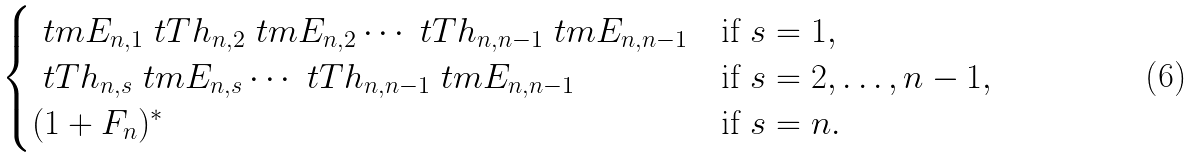Convert formula to latex. <formula><loc_0><loc_0><loc_500><loc_500>\begin{cases} \ t m E _ { n , 1 } \ t T h _ { n , 2 } \ t m E _ { n , 2 } \cdots \ t T h _ { n , n - 1 } \ t m E _ { n , n - 1 } & \text {if } s = 1 , \\ \ t T h _ { n , s } \ t m E _ { n , s } \cdots \ t T h _ { n , n - 1 } \ t m E _ { n , n - 1 } & \text {if } s = 2 , \dots , n - 1 , \\ ( 1 + F _ { n } ) ^ { * } & \text {if } s = n . \\ \end{cases}</formula> 